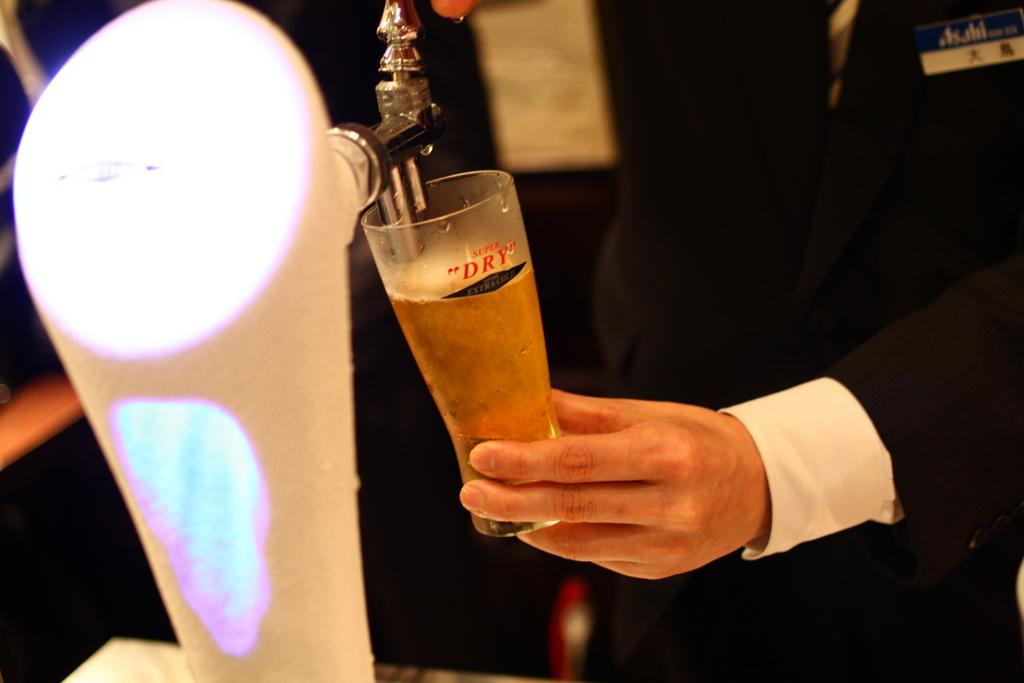<image>
Give a short and clear explanation of the subsequent image. Pouring a glass of beer that is labeled super DRY 